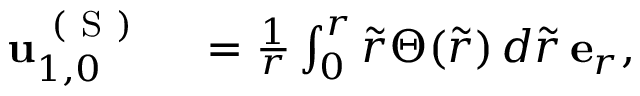<formula> <loc_0><loc_0><loc_500><loc_500>\begin{array} { r l } { u _ { 1 , 0 } ^ { ( S ) } } & = \frac { 1 } { r } \int _ { 0 } ^ { r } \tilde { r } \Theta ( \tilde { r } ) \, d \tilde { r } \, e _ { r } , } \end{array}</formula> 